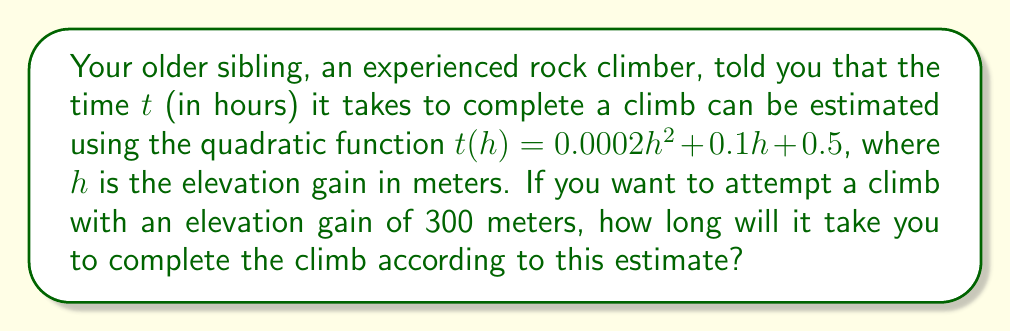Could you help me with this problem? To solve this problem, we need to follow these steps:

1. Identify the given quadratic function:
   $t(h) = 0.0002h^2 + 0.1h + 0.5$

2. Substitute the elevation gain $h = 300$ meters into the function:
   $t(300) = 0.0002(300)^2 + 0.1(300) + 0.5$

3. Calculate the squared term:
   $(300)^2 = 90,000$

4. Multiply the coefficients:
   $0.0002 \times 90,000 = 18$
   $0.1 \times 300 = 30$

5. Add all terms:
   $t(300) = 18 + 30 + 0.5 = 48.5$

Therefore, the estimated time to complete the climb is 48.5 hours.
Answer: 48.5 hours 